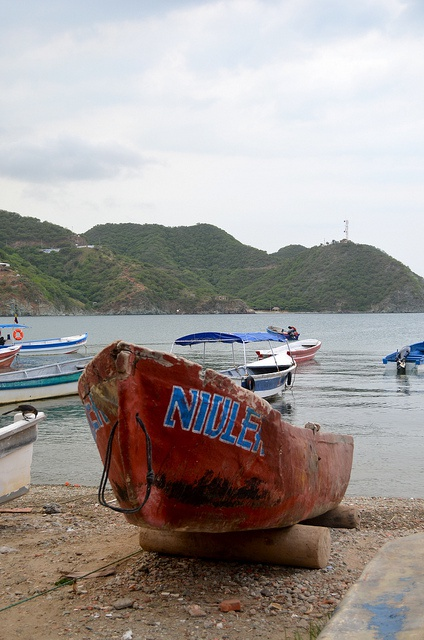Describe the objects in this image and their specific colors. I can see boat in lightgray, maroon, black, and gray tones, boat in lightgray, darkgray, gray, and black tones, boat in lightgray, darkgray, and gray tones, boat in lightgray, darkgray, teal, gray, and darkblue tones, and boat in lightgray, darkgray, and blue tones in this image. 